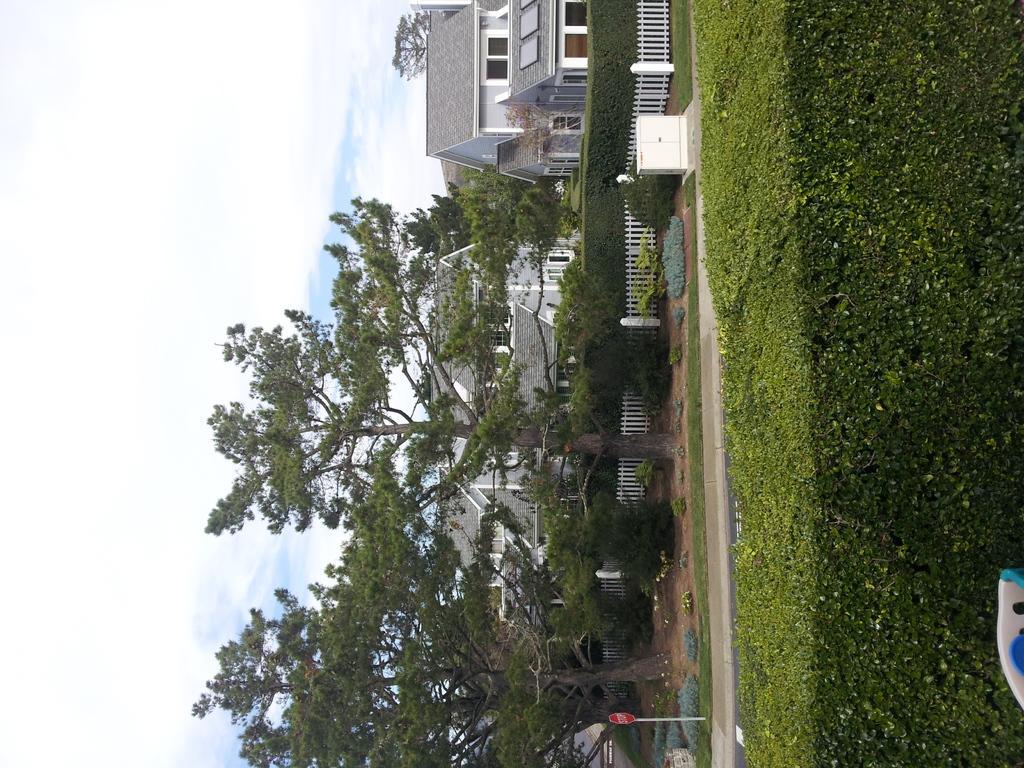In one or two sentences, can you explain what this image depicts? In this image we can see the lawn, stop board, fence, trees, houses and the sky with clouds in the background. 